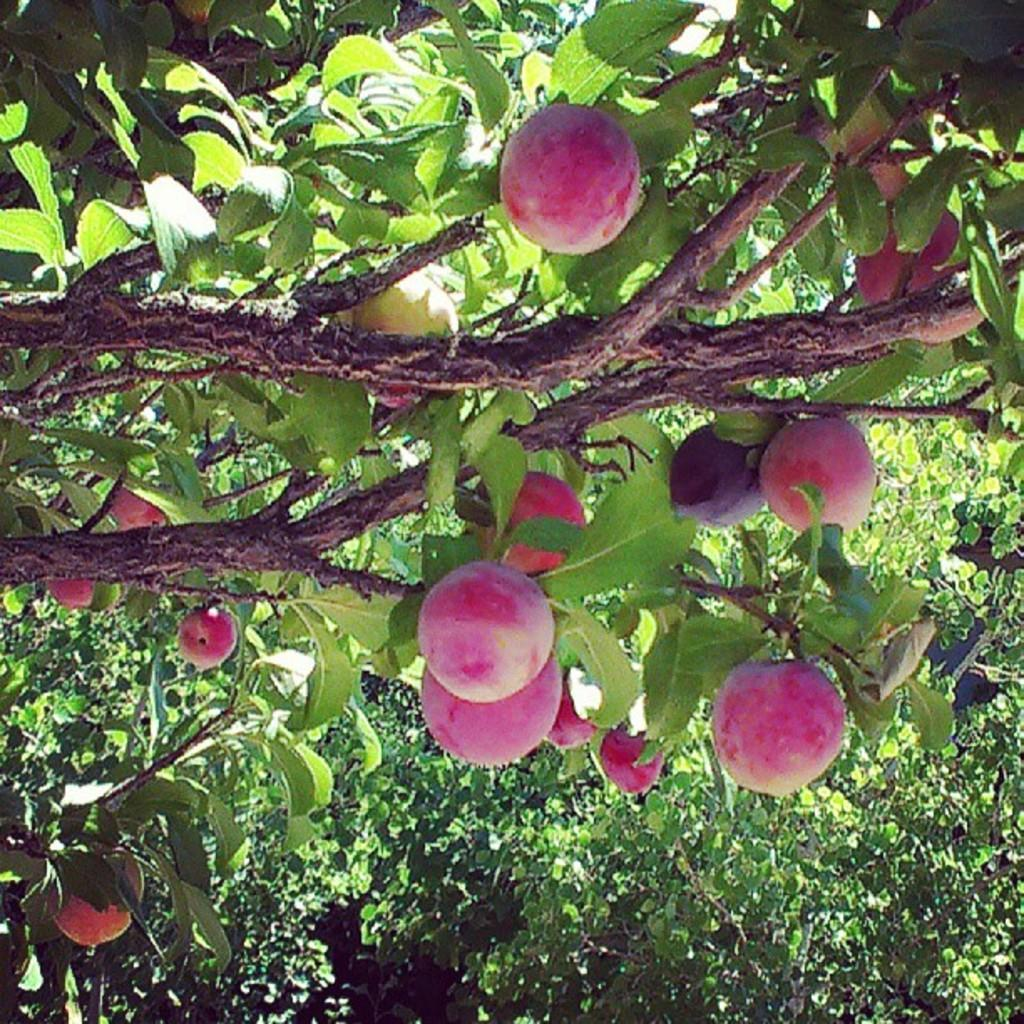What is the main object in the image? There is a tree in the image. Can you describe the colors of the tree? The tree has green and brown colors. What else can be seen on the tree? There are fruits on the tree. What colors do the fruits have? The fruits have pink and red colors. How many sisters are depicted in the image? There are no sisters depicted in the image; it features a tree with fruits. What type of crime is being committed in the image? There is no crime depicted in the image; it features a tree with fruits. 